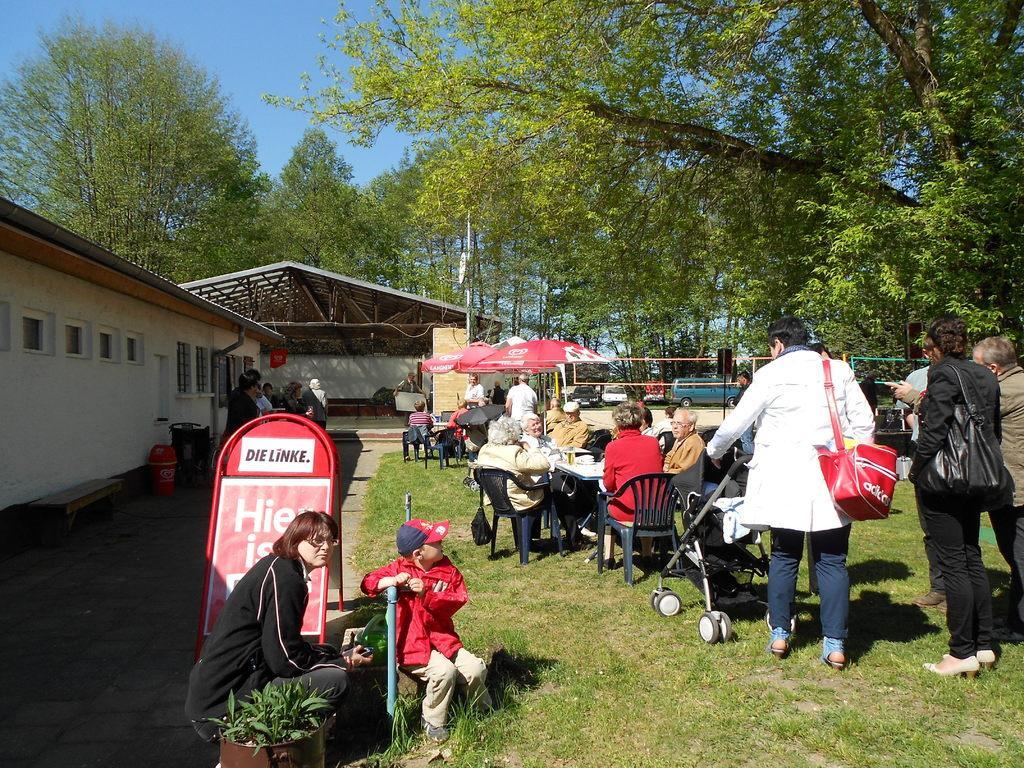In one or two sentences, can you explain what this image depicts? In this image we can see people sitting on the chairs and tables are placed in front of them. On the tables we can see cutlery and beverage tumblers. In addition to this there are people standing on the ground and one of them is holding a baby pram, people sitting on the pavement, advertising boards, bins, benches, sheds, trees, poles, motor vehicles and sky. 